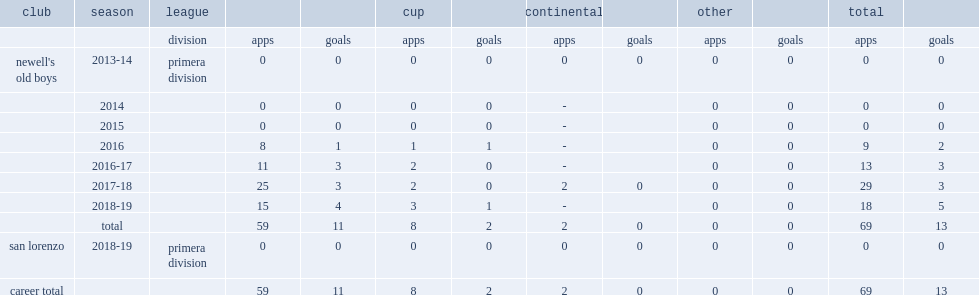Which club did fertoli play for in 2013-14? Newell's old boys. 